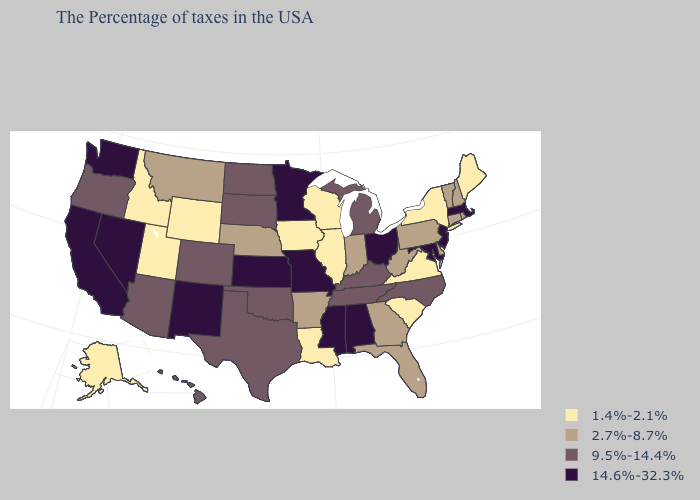Name the states that have a value in the range 14.6%-32.3%?
Give a very brief answer. Massachusetts, New Jersey, Maryland, Ohio, Alabama, Mississippi, Missouri, Minnesota, Kansas, New Mexico, Nevada, California, Washington. Which states hav the highest value in the Northeast?
Keep it brief. Massachusetts, New Jersey. Name the states that have a value in the range 9.5%-14.4%?
Give a very brief answer. North Carolina, Michigan, Kentucky, Tennessee, Oklahoma, Texas, South Dakota, North Dakota, Colorado, Arizona, Oregon, Hawaii. How many symbols are there in the legend?
Short answer required. 4. What is the lowest value in states that border Arizona?
Quick response, please. 1.4%-2.1%. What is the value of Hawaii?
Keep it brief. 9.5%-14.4%. Name the states that have a value in the range 1.4%-2.1%?
Quick response, please. Maine, New York, Virginia, South Carolina, Wisconsin, Illinois, Louisiana, Iowa, Wyoming, Utah, Idaho, Alaska. What is the value of Hawaii?
Keep it brief. 9.5%-14.4%. Does the first symbol in the legend represent the smallest category?
Give a very brief answer. Yes. Does California have the lowest value in the West?
Be succinct. No. Does Idaho have the lowest value in the West?
Short answer required. Yes. Does Texas have a lower value than Georgia?
Quick response, please. No. Is the legend a continuous bar?
Answer briefly. No. What is the highest value in the USA?
Quick response, please. 14.6%-32.3%. 